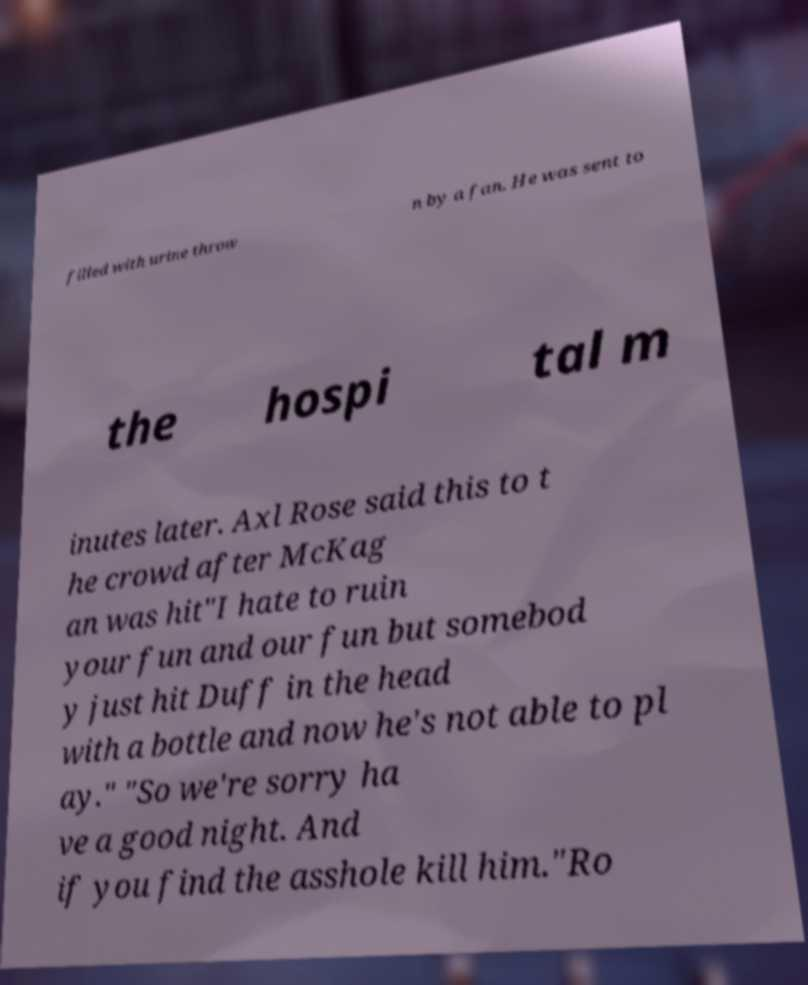I need the written content from this picture converted into text. Can you do that? filled with urine throw n by a fan. He was sent to the hospi tal m inutes later. Axl Rose said this to t he crowd after McKag an was hit"I hate to ruin your fun and our fun but somebod y just hit Duff in the head with a bottle and now he's not able to pl ay." "So we're sorry ha ve a good night. And if you find the asshole kill him."Ro 